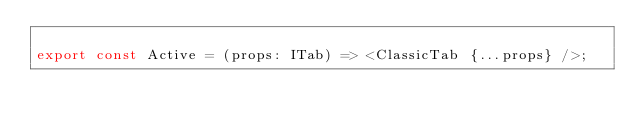<code> <loc_0><loc_0><loc_500><loc_500><_TypeScript_>
export const Active = (props: ITab) => <ClassicTab {...props} />;
</code> 